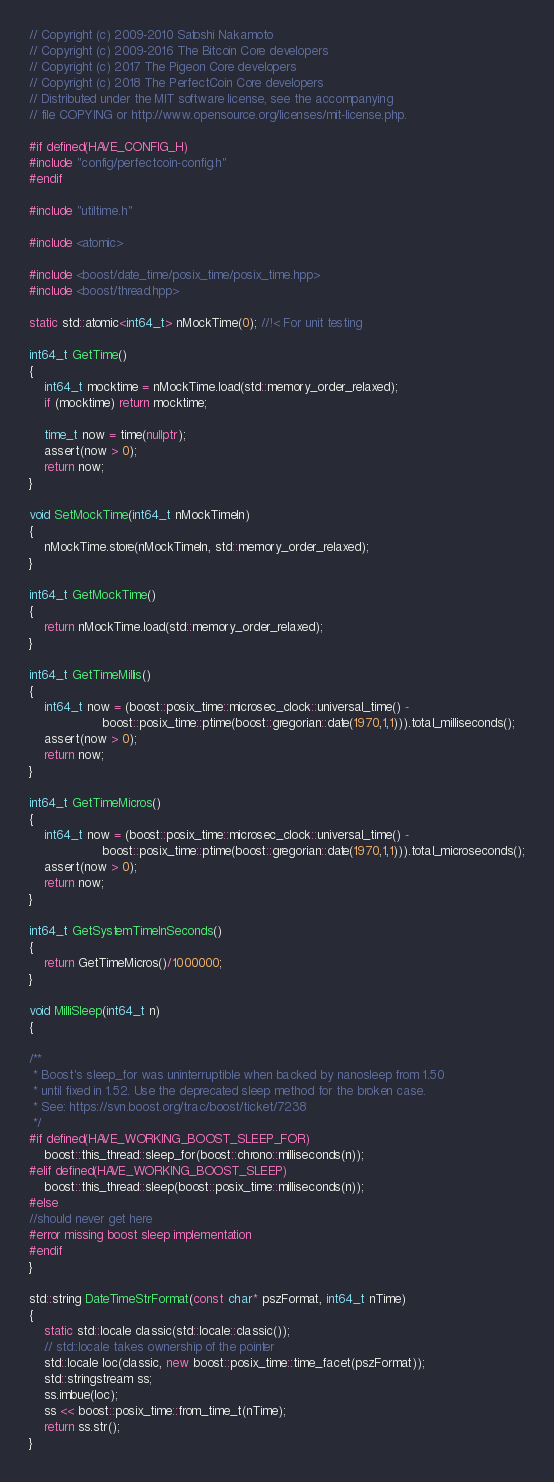<code> <loc_0><loc_0><loc_500><loc_500><_C++_>// Copyright (c) 2009-2010 Satoshi Nakamoto
// Copyright (c) 2009-2016 The Bitcoin Core developers
// Copyright (c) 2017 The Pigeon Core developers
// Copyright (c) 2018 The PerfectCoin Core developers
// Distributed under the MIT software license, see the accompanying
// file COPYING or http://www.opensource.org/licenses/mit-license.php.

#if defined(HAVE_CONFIG_H)
#include "config/perfectcoin-config.h"
#endif

#include "utiltime.h"

#include <atomic>

#include <boost/date_time/posix_time/posix_time.hpp>
#include <boost/thread.hpp>

static std::atomic<int64_t> nMockTime(0); //!< For unit testing

int64_t GetTime()
{
    int64_t mocktime = nMockTime.load(std::memory_order_relaxed);
    if (mocktime) return mocktime;

    time_t now = time(nullptr);
    assert(now > 0);
    return now;
}

void SetMockTime(int64_t nMockTimeIn)
{
    nMockTime.store(nMockTimeIn, std::memory_order_relaxed);
}

int64_t GetMockTime()
{
    return nMockTime.load(std::memory_order_relaxed);
}

int64_t GetTimeMillis()
{
    int64_t now = (boost::posix_time::microsec_clock::universal_time() -
                   boost::posix_time::ptime(boost::gregorian::date(1970,1,1))).total_milliseconds();
    assert(now > 0);
    return now;
}

int64_t GetTimeMicros()
{
    int64_t now = (boost::posix_time::microsec_clock::universal_time() -
                   boost::posix_time::ptime(boost::gregorian::date(1970,1,1))).total_microseconds();
    assert(now > 0);
    return now;
}

int64_t GetSystemTimeInSeconds()
{
    return GetTimeMicros()/1000000;
}

void MilliSleep(int64_t n)
{

/**
 * Boost's sleep_for was uninterruptible when backed by nanosleep from 1.50
 * until fixed in 1.52. Use the deprecated sleep method for the broken case.
 * See: https://svn.boost.org/trac/boost/ticket/7238
 */
#if defined(HAVE_WORKING_BOOST_SLEEP_FOR)
    boost::this_thread::sleep_for(boost::chrono::milliseconds(n));
#elif defined(HAVE_WORKING_BOOST_SLEEP)
    boost::this_thread::sleep(boost::posix_time::milliseconds(n));
#else
//should never get here
#error missing boost sleep implementation
#endif
}

std::string DateTimeStrFormat(const char* pszFormat, int64_t nTime)
{
    static std::locale classic(std::locale::classic());
    // std::locale takes ownership of the pointer
    std::locale loc(classic, new boost::posix_time::time_facet(pszFormat));
    std::stringstream ss;
    ss.imbue(loc);
    ss << boost::posix_time::from_time_t(nTime);
    return ss.str();
}
</code> 